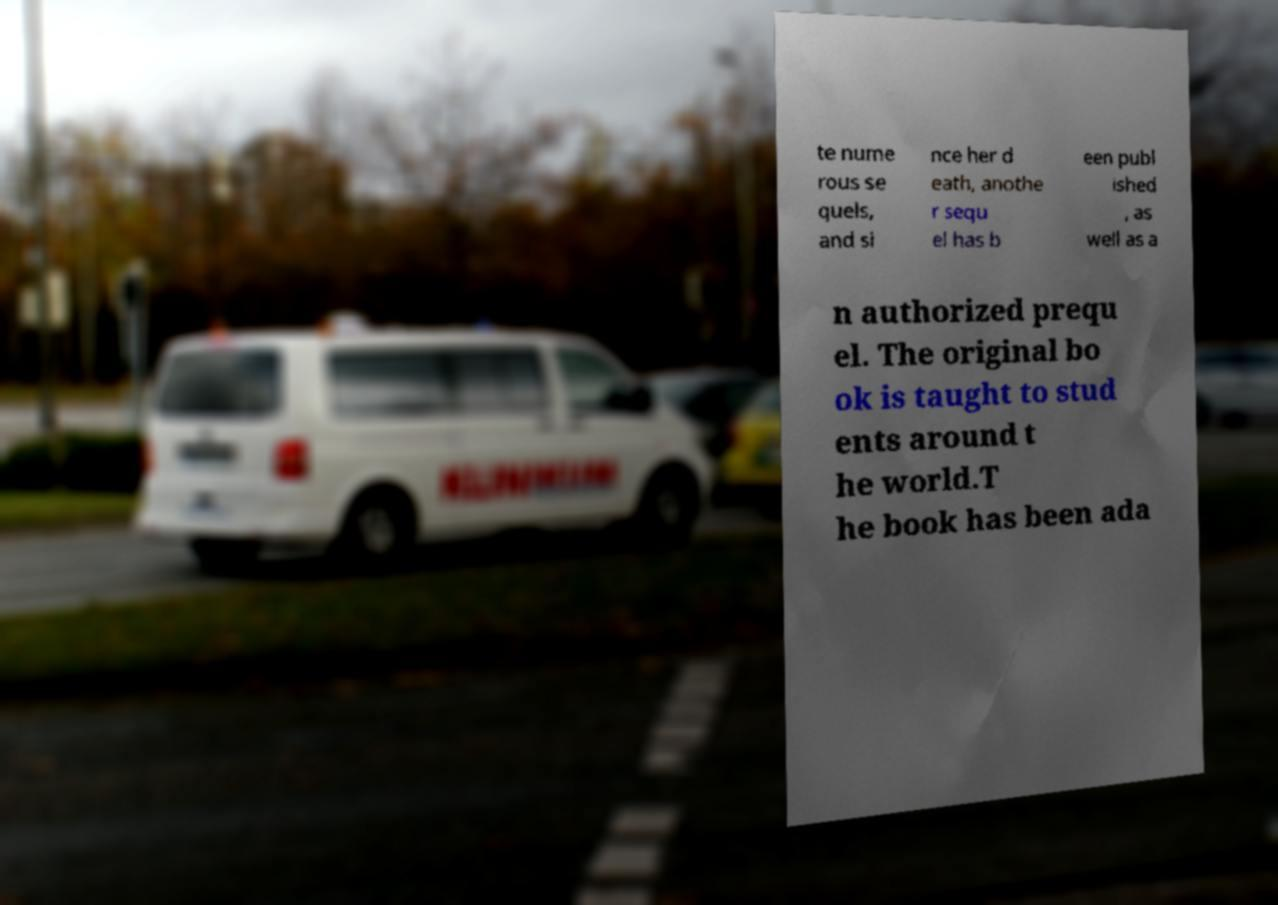For documentation purposes, I need the text within this image transcribed. Could you provide that? te nume rous se quels, and si nce her d eath, anothe r sequ el has b een publ ished , as well as a n authorized prequ el. The original bo ok is taught to stud ents around t he world.T he book has been ada 